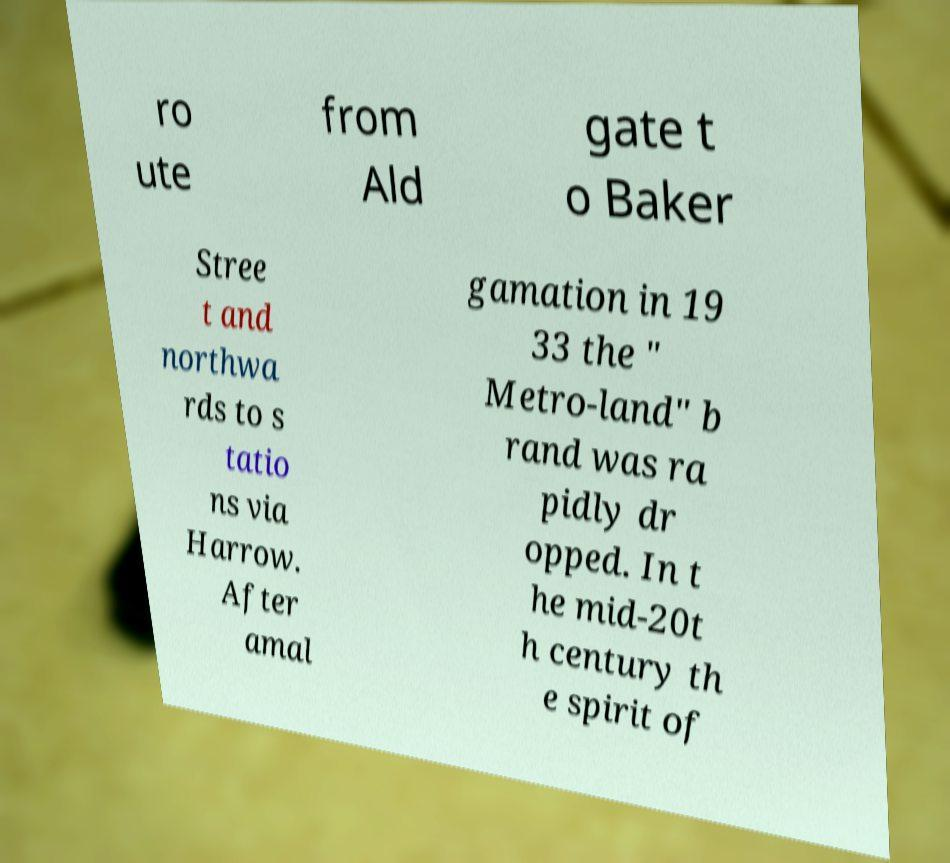What messages or text are displayed in this image? I need them in a readable, typed format. ro ute from Ald gate t o Baker Stree t and northwa rds to s tatio ns via Harrow. After amal gamation in 19 33 the " Metro-land" b rand was ra pidly dr opped. In t he mid-20t h century th e spirit of 